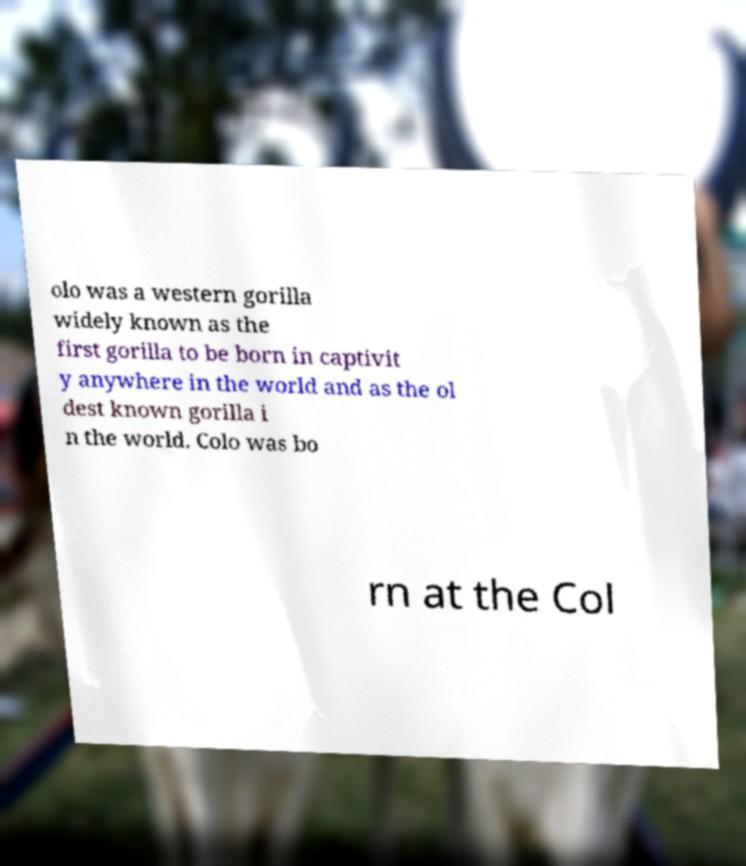Could you extract and type out the text from this image? olo was a western gorilla widely known as the first gorilla to be born in captivit y anywhere in the world and as the ol dest known gorilla i n the world. Colo was bo rn at the Col 